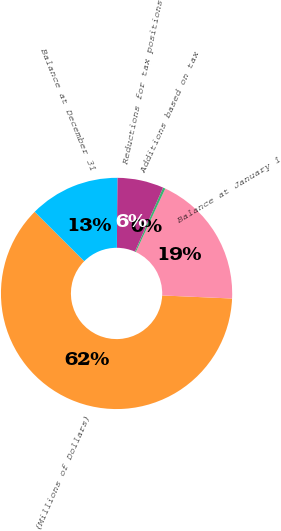Convert chart to OTSL. <chart><loc_0><loc_0><loc_500><loc_500><pie_chart><fcel>(Millions of Dollars)<fcel>Balance at January 1<fcel>Additions based on tax<fcel>Reductions for tax positions<fcel>Balance at December 31<nl><fcel>61.78%<fcel>18.77%<fcel>0.34%<fcel>6.48%<fcel>12.63%<nl></chart> 